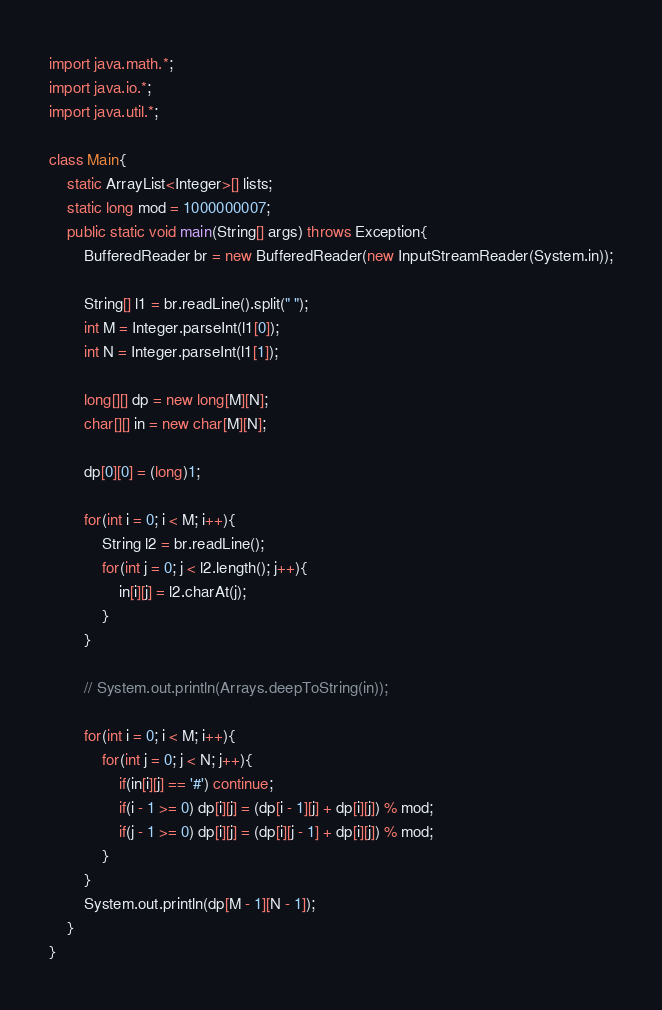<code> <loc_0><loc_0><loc_500><loc_500><_Java_>import java.math.*;
import java.io.*;
import java.util.*;
 
class Main{
    static ArrayList<Integer>[] lists;
    static long mod = 1000000007;
    public static void main(String[] args) throws Exception{
        BufferedReader br = new BufferedReader(new InputStreamReader(System.in));
        
        String[] l1 = br.readLine().split(" ");
        int M = Integer.parseInt(l1[0]);
        int N = Integer.parseInt(l1[1]);

        long[][] dp = new long[M][N];
        char[][] in = new char[M][N];

        dp[0][0] = (long)1;
        
        for(int i = 0; i < M; i++){
            String l2 = br.readLine();
            for(int j = 0; j < l2.length(); j++){
                in[i][j] = l2.charAt(j);
            }
        }

        // System.out.println(Arrays.deepToString(in));

        for(int i = 0; i < M; i++){
            for(int j = 0; j < N; j++){
                if(in[i][j] == '#') continue;
                if(i - 1 >= 0) dp[i][j] = (dp[i - 1][j] + dp[i][j]) % mod;
                if(j - 1 >= 0) dp[i][j] = (dp[i][j - 1] + dp[i][j]) % mod;
            }
        }
        System.out.println(dp[M - 1][N - 1]);
    }
}</code> 